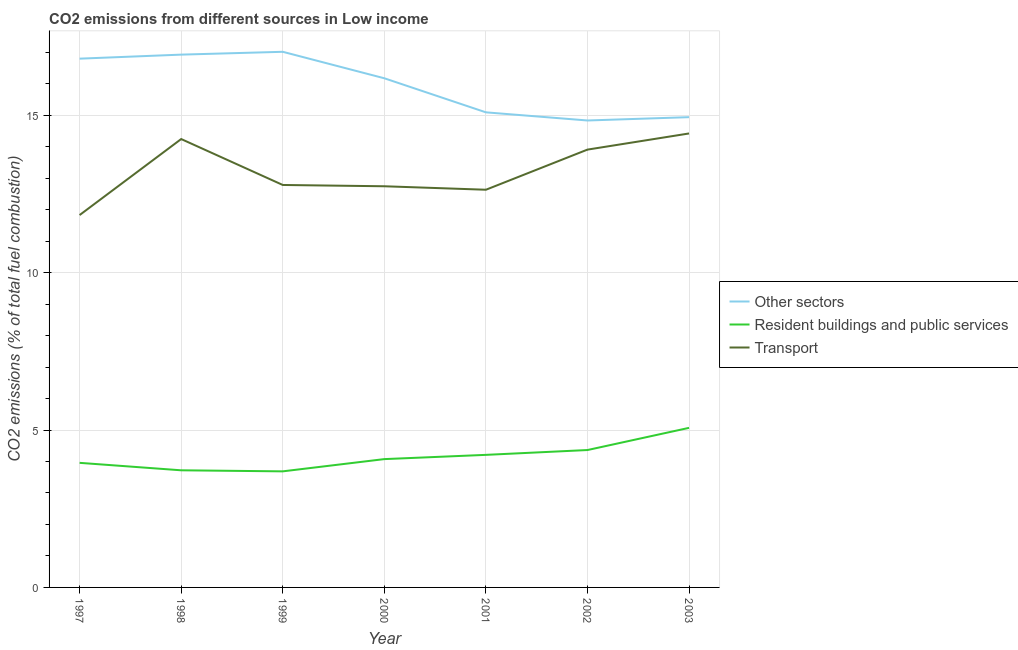How many different coloured lines are there?
Provide a succinct answer. 3. Does the line corresponding to percentage of co2 emissions from resident buildings and public services intersect with the line corresponding to percentage of co2 emissions from other sectors?
Ensure brevity in your answer.  No. Is the number of lines equal to the number of legend labels?
Give a very brief answer. Yes. What is the percentage of co2 emissions from resident buildings and public services in 2002?
Your response must be concise. 4.36. Across all years, what is the maximum percentage of co2 emissions from other sectors?
Provide a succinct answer. 17.01. Across all years, what is the minimum percentage of co2 emissions from resident buildings and public services?
Your answer should be very brief. 3.69. In which year was the percentage of co2 emissions from transport maximum?
Your answer should be very brief. 2003. In which year was the percentage of co2 emissions from resident buildings and public services minimum?
Keep it short and to the point. 1999. What is the total percentage of co2 emissions from other sectors in the graph?
Your response must be concise. 111.78. What is the difference between the percentage of co2 emissions from transport in 2000 and that in 2002?
Give a very brief answer. -1.16. What is the difference between the percentage of co2 emissions from transport in 1999 and the percentage of co2 emissions from resident buildings and public services in 2000?
Provide a short and direct response. 8.71. What is the average percentage of co2 emissions from resident buildings and public services per year?
Your answer should be compact. 4.16. In the year 2000, what is the difference between the percentage of co2 emissions from other sectors and percentage of co2 emissions from resident buildings and public services?
Your answer should be very brief. 12.1. What is the ratio of the percentage of co2 emissions from transport in 2001 to that in 2003?
Keep it short and to the point. 0.88. Is the difference between the percentage of co2 emissions from other sectors in 2001 and 2003 greater than the difference between the percentage of co2 emissions from transport in 2001 and 2003?
Your answer should be compact. Yes. What is the difference between the highest and the second highest percentage of co2 emissions from resident buildings and public services?
Keep it short and to the point. 0.7. What is the difference between the highest and the lowest percentage of co2 emissions from transport?
Your answer should be very brief. 2.59. In how many years, is the percentage of co2 emissions from transport greater than the average percentage of co2 emissions from transport taken over all years?
Offer a very short reply. 3. Is the percentage of co2 emissions from other sectors strictly less than the percentage of co2 emissions from resident buildings and public services over the years?
Keep it short and to the point. No. Are the values on the major ticks of Y-axis written in scientific E-notation?
Offer a very short reply. No. Does the graph contain any zero values?
Offer a very short reply. No. What is the title of the graph?
Ensure brevity in your answer.  CO2 emissions from different sources in Low income. Does "Ores and metals" appear as one of the legend labels in the graph?
Keep it short and to the point. No. What is the label or title of the X-axis?
Keep it short and to the point. Year. What is the label or title of the Y-axis?
Provide a short and direct response. CO2 emissions (% of total fuel combustion). What is the CO2 emissions (% of total fuel combustion) in Other sectors in 1997?
Give a very brief answer. 16.8. What is the CO2 emissions (% of total fuel combustion) in Resident buildings and public services in 1997?
Your answer should be compact. 3.96. What is the CO2 emissions (% of total fuel combustion) in Transport in 1997?
Keep it short and to the point. 11.83. What is the CO2 emissions (% of total fuel combustion) in Other sectors in 1998?
Make the answer very short. 16.93. What is the CO2 emissions (% of total fuel combustion) of Resident buildings and public services in 1998?
Provide a succinct answer. 3.72. What is the CO2 emissions (% of total fuel combustion) of Transport in 1998?
Give a very brief answer. 14.24. What is the CO2 emissions (% of total fuel combustion) of Other sectors in 1999?
Your response must be concise. 17.01. What is the CO2 emissions (% of total fuel combustion) of Resident buildings and public services in 1999?
Your response must be concise. 3.69. What is the CO2 emissions (% of total fuel combustion) in Transport in 1999?
Your answer should be very brief. 12.78. What is the CO2 emissions (% of total fuel combustion) of Other sectors in 2000?
Your answer should be very brief. 16.17. What is the CO2 emissions (% of total fuel combustion) in Resident buildings and public services in 2000?
Give a very brief answer. 4.08. What is the CO2 emissions (% of total fuel combustion) of Transport in 2000?
Make the answer very short. 12.74. What is the CO2 emissions (% of total fuel combustion) in Other sectors in 2001?
Provide a short and direct response. 15.09. What is the CO2 emissions (% of total fuel combustion) of Resident buildings and public services in 2001?
Offer a terse response. 4.21. What is the CO2 emissions (% of total fuel combustion) in Transport in 2001?
Your response must be concise. 12.63. What is the CO2 emissions (% of total fuel combustion) in Other sectors in 2002?
Provide a short and direct response. 14.83. What is the CO2 emissions (% of total fuel combustion) of Resident buildings and public services in 2002?
Your answer should be very brief. 4.36. What is the CO2 emissions (% of total fuel combustion) in Transport in 2002?
Provide a short and direct response. 13.91. What is the CO2 emissions (% of total fuel combustion) of Other sectors in 2003?
Your response must be concise. 14.94. What is the CO2 emissions (% of total fuel combustion) of Resident buildings and public services in 2003?
Keep it short and to the point. 5.07. What is the CO2 emissions (% of total fuel combustion) in Transport in 2003?
Offer a very short reply. 14.42. Across all years, what is the maximum CO2 emissions (% of total fuel combustion) in Other sectors?
Your answer should be compact. 17.01. Across all years, what is the maximum CO2 emissions (% of total fuel combustion) of Resident buildings and public services?
Offer a terse response. 5.07. Across all years, what is the maximum CO2 emissions (% of total fuel combustion) in Transport?
Your response must be concise. 14.42. Across all years, what is the minimum CO2 emissions (% of total fuel combustion) of Other sectors?
Your response must be concise. 14.83. Across all years, what is the minimum CO2 emissions (% of total fuel combustion) of Resident buildings and public services?
Keep it short and to the point. 3.69. Across all years, what is the minimum CO2 emissions (% of total fuel combustion) of Transport?
Provide a succinct answer. 11.83. What is the total CO2 emissions (% of total fuel combustion) in Other sectors in the graph?
Give a very brief answer. 111.78. What is the total CO2 emissions (% of total fuel combustion) of Resident buildings and public services in the graph?
Ensure brevity in your answer.  29.09. What is the total CO2 emissions (% of total fuel combustion) of Transport in the graph?
Offer a very short reply. 92.56. What is the difference between the CO2 emissions (% of total fuel combustion) of Other sectors in 1997 and that in 1998?
Offer a very short reply. -0.13. What is the difference between the CO2 emissions (% of total fuel combustion) of Resident buildings and public services in 1997 and that in 1998?
Give a very brief answer. 0.24. What is the difference between the CO2 emissions (% of total fuel combustion) of Transport in 1997 and that in 1998?
Ensure brevity in your answer.  -2.41. What is the difference between the CO2 emissions (% of total fuel combustion) of Other sectors in 1997 and that in 1999?
Keep it short and to the point. -0.22. What is the difference between the CO2 emissions (% of total fuel combustion) in Resident buildings and public services in 1997 and that in 1999?
Your response must be concise. 0.27. What is the difference between the CO2 emissions (% of total fuel combustion) of Transport in 1997 and that in 1999?
Provide a short and direct response. -0.96. What is the difference between the CO2 emissions (% of total fuel combustion) of Other sectors in 1997 and that in 2000?
Provide a succinct answer. 0.62. What is the difference between the CO2 emissions (% of total fuel combustion) in Resident buildings and public services in 1997 and that in 2000?
Provide a short and direct response. -0.12. What is the difference between the CO2 emissions (% of total fuel combustion) of Transport in 1997 and that in 2000?
Provide a short and direct response. -0.91. What is the difference between the CO2 emissions (% of total fuel combustion) of Other sectors in 1997 and that in 2001?
Offer a terse response. 1.71. What is the difference between the CO2 emissions (% of total fuel combustion) of Resident buildings and public services in 1997 and that in 2001?
Provide a short and direct response. -0.25. What is the difference between the CO2 emissions (% of total fuel combustion) in Transport in 1997 and that in 2001?
Provide a succinct answer. -0.8. What is the difference between the CO2 emissions (% of total fuel combustion) of Other sectors in 1997 and that in 2002?
Keep it short and to the point. 1.96. What is the difference between the CO2 emissions (% of total fuel combustion) in Resident buildings and public services in 1997 and that in 2002?
Provide a short and direct response. -0.41. What is the difference between the CO2 emissions (% of total fuel combustion) in Transport in 1997 and that in 2002?
Provide a succinct answer. -2.08. What is the difference between the CO2 emissions (% of total fuel combustion) in Other sectors in 1997 and that in 2003?
Your answer should be compact. 1.86. What is the difference between the CO2 emissions (% of total fuel combustion) of Resident buildings and public services in 1997 and that in 2003?
Ensure brevity in your answer.  -1.11. What is the difference between the CO2 emissions (% of total fuel combustion) of Transport in 1997 and that in 2003?
Provide a succinct answer. -2.59. What is the difference between the CO2 emissions (% of total fuel combustion) in Other sectors in 1998 and that in 1999?
Offer a terse response. -0.09. What is the difference between the CO2 emissions (% of total fuel combustion) in Resident buildings and public services in 1998 and that in 1999?
Offer a terse response. 0.03. What is the difference between the CO2 emissions (% of total fuel combustion) of Transport in 1998 and that in 1999?
Make the answer very short. 1.46. What is the difference between the CO2 emissions (% of total fuel combustion) in Other sectors in 1998 and that in 2000?
Provide a short and direct response. 0.75. What is the difference between the CO2 emissions (% of total fuel combustion) in Resident buildings and public services in 1998 and that in 2000?
Make the answer very short. -0.36. What is the difference between the CO2 emissions (% of total fuel combustion) in Transport in 1998 and that in 2000?
Provide a short and direct response. 1.5. What is the difference between the CO2 emissions (% of total fuel combustion) in Other sectors in 1998 and that in 2001?
Ensure brevity in your answer.  1.83. What is the difference between the CO2 emissions (% of total fuel combustion) of Resident buildings and public services in 1998 and that in 2001?
Offer a very short reply. -0.49. What is the difference between the CO2 emissions (% of total fuel combustion) in Transport in 1998 and that in 2001?
Your response must be concise. 1.61. What is the difference between the CO2 emissions (% of total fuel combustion) in Other sectors in 1998 and that in 2002?
Give a very brief answer. 2.09. What is the difference between the CO2 emissions (% of total fuel combustion) in Resident buildings and public services in 1998 and that in 2002?
Ensure brevity in your answer.  -0.64. What is the difference between the CO2 emissions (% of total fuel combustion) of Transport in 1998 and that in 2002?
Keep it short and to the point. 0.34. What is the difference between the CO2 emissions (% of total fuel combustion) in Other sectors in 1998 and that in 2003?
Provide a succinct answer. 1.99. What is the difference between the CO2 emissions (% of total fuel combustion) in Resident buildings and public services in 1998 and that in 2003?
Give a very brief answer. -1.35. What is the difference between the CO2 emissions (% of total fuel combustion) of Transport in 1998 and that in 2003?
Your answer should be compact. -0.18. What is the difference between the CO2 emissions (% of total fuel combustion) in Other sectors in 1999 and that in 2000?
Your answer should be compact. 0.84. What is the difference between the CO2 emissions (% of total fuel combustion) in Resident buildings and public services in 1999 and that in 2000?
Give a very brief answer. -0.39. What is the difference between the CO2 emissions (% of total fuel combustion) in Transport in 1999 and that in 2000?
Provide a succinct answer. 0.04. What is the difference between the CO2 emissions (% of total fuel combustion) in Other sectors in 1999 and that in 2001?
Offer a terse response. 1.92. What is the difference between the CO2 emissions (% of total fuel combustion) in Resident buildings and public services in 1999 and that in 2001?
Offer a very short reply. -0.52. What is the difference between the CO2 emissions (% of total fuel combustion) of Transport in 1999 and that in 2001?
Your answer should be very brief. 0.15. What is the difference between the CO2 emissions (% of total fuel combustion) of Other sectors in 1999 and that in 2002?
Your response must be concise. 2.18. What is the difference between the CO2 emissions (% of total fuel combustion) of Resident buildings and public services in 1999 and that in 2002?
Provide a succinct answer. -0.68. What is the difference between the CO2 emissions (% of total fuel combustion) in Transport in 1999 and that in 2002?
Offer a very short reply. -1.12. What is the difference between the CO2 emissions (% of total fuel combustion) of Other sectors in 1999 and that in 2003?
Provide a succinct answer. 2.08. What is the difference between the CO2 emissions (% of total fuel combustion) in Resident buildings and public services in 1999 and that in 2003?
Provide a succinct answer. -1.38. What is the difference between the CO2 emissions (% of total fuel combustion) of Transport in 1999 and that in 2003?
Give a very brief answer. -1.64. What is the difference between the CO2 emissions (% of total fuel combustion) of Other sectors in 2000 and that in 2001?
Your answer should be very brief. 1.08. What is the difference between the CO2 emissions (% of total fuel combustion) of Resident buildings and public services in 2000 and that in 2001?
Give a very brief answer. -0.13. What is the difference between the CO2 emissions (% of total fuel combustion) of Transport in 2000 and that in 2001?
Ensure brevity in your answer.  0.11. What is the difference between the CO2 emissions (% of total fuel combustion) of Other sectors in 2000 and that in 2002?
Offer a terse response. 1.34. What is the difference between the CO2 emissions (% of total fuel combustion) in Resident buildings and public services in 2000 and that in 2002?
Your answer should be compact. -0.29. What is the difference between the CO2 emissions (% of total fuel combustion) of Transport in 2000 and that in 2002?
Keep it short and to the point. -1.16. What is the difference between the CO2 emissions (% of total fuel combustion) in Other sectors in 2000 and that in 2003?
Offer a very short reply. 1.24. What is the difference between the CO2 emissions (% of total fuel combustion) of Resident buildings and public services in 2000 and that in 2003?
Ensure brevity in your answer.  -0.99. What is the difference between the CO2 emissions (% of total fuel combustion) of Transport in 2000 and that in 2003?
Make the answer very short. -1.68. What is the difference between the CO2 emissions (% of total fuel combustion) in Other sectors in 2001 and that in 2002?
Keep it short and to the point. 0.26. What is the difference between the CO2 emissions (% of total fuel combustion) of Resident buildings and public services in 2001 and that in 2002?
Ensure brevity in your answer.  -0.15. What is the difference between the CO2 emissions (% of total fuel combustion) in Transport in 2001 and that in 2002?
Offer a terse response. -1.27. What is the difference between the CO2 emissions (% of total fuel combustion) of Other sectors in 2001 and that in 2003?
Your answer should be very brief. 0.15. What is the difference between the CO2 emissions (% of total fuel combustion) in Resident buildings and public services in 2001 and that in 2003?
Give a very brief answer. -0.86. What is the difference between the CO2 emissions (% of total fuel combustion) in Transport in 2001 and that in 2003?
Offer a terse response. -1.79. What is the difference between the CO2 emissions (% of total fuel combustion) of Other sectors in 2002 and that in 2003?
Provide a succinct answer. -0.11. What is the difference between the CO2 emissions (% of total fuel combustion) of Resident buildings and public services in 2002 and that in 2003?
Your answer should be very brief. -0.7. What is the difference between the CO2 emissions (% of total fuel combustion) of Transport in 2002 and that in 2003?
Your answer should be very brief. -0.51. What is the difference between the CO2 emissions (% of total fuel combustion) of Other sectors in 1997 and the CO2 emissions (% of total fuel combustion) of Resident buildings and public services in 1998?
Keep it short and to the point. 13.08. What is the difference between the CO2 emissions (% of total fuel combustion) in Other sectors in 1997 and the CO2 emissions (% of total fuel combustion) in Transport in 1998?
Your answer should be compact. 2.55. What is the difference between the CO2 emissions (% of total fuel combustion) in Resident buildings and public services in 1997 and the CO2 emissions (% of total fuel combustion) in Transport in 1998?
Keep it short and to the point. -10.29. What is the difference between the CO2 emissions (% of total fuel combustion) in Other sectors in 1997 and the CO2 emissions (% of total fuel combustion) in Resident buildings and public services in 1999?
Provide a short and direct response. 13.11. What is the difference between the CO2 emissions (% of total fuel combustion) in Other sectors in 1997 and the CO2 emissions (% of total fuel combustion) in Transport in 1999?
Your response must be concise. 4.01. What is the difference between the CO2 emissions (% of total fuel combustion) in Resident buildings and public services in 1997 and the CO2 emissions (% of total fuel combustion) in Transport in 1999?
Keep it short and to the point. -8.83. What is the difference between the CO2 emissions (% of total fuel combustion) of Other sectors in 1997 and the CO2 emissions (% of total fuel combustion) of Resident buildings and public services in 2000?
Provide a short and direct response. 12.72. What is the difference between the CO2 emissions (% of total fuel combustion) of Other sectors in 1997 and the CO2 emissions (% of total fuel combustion) of Transport in 2000?
Ensure brevity in your answer.  4.05. What is the difference between the CO2 emissions (% of total fuel combustion) in Resident buildings and public services in 1997 and the CO2 emissions (% of total fuel combustion) in Transport in 2000?
Your response must be concise. -8.79. What is the difference between the CO2 emissions (% of total fuel combustion) of Other sectors in 1997 and the CO2 emissions (% of total fuel combustion) of Resident buildings and public services in 2001?
Give a very brief answer. 12.59. What is the difference between the CO2 emissions (% of total fuel combustion) of Other sectors in 1997 and the CO2 emissions (% of total fuel combustion) of Transport in 2001?
Your answer should be very brief. 4.16. What is the difference between the CO2 emissions (% of total fuel combustion) in Resident buildings and public services in 1997 and the CO2 emissions (% of total fuel combustion) in Transport in 2001?
Keep it short and to the point. -8.68. What is the difference between the CO2 emissions (% of total fuel combustion) in Other sectors in 1997 and the CO2 emissions (% of total fuel combustion) in Resident buildings and public services in 2002?
Give a very brief answer. 12.43. What is the difference between the CO2 emissions (% of total fuel combustion) in Other sectors in 1997 and the CO2 emissions (% of total fuel combustion) in Transport in 2002?
Keep it short and to the point. 2.89. What is the difference between the CO2 emissions (% of total fuel combustion) in Resident buildings and public services in 1997 and the CO2 emissions (% of total fuel combustion) in Transport in 2002?
Offer a terse response. -9.95. What is the difference between the CO2 emissions (% of total fuel combustion) of Other sectors in 1997 and the CO2 emissions (% of total fuel combustion) of Resident buildings and public services in 2003?
Keep it short and to the point. 11.73. What is the difference between the CO2 emissions (% of total fuel combustion) in Other sectors in 1997 and the CO2 emissions (% of total fuel combustion) in Transport in 2003?
Make the answer very short. 2.38. What is the difference between the CO2 emissions (% of total fuel combustion) in Resident buildings and public services in 1997 and the CO2 emissions (% of total fuel combustion) in Transport in 2003?
Provide a short and direct response. -10.46. What is the difference between the CO2 emissions (% of total fuel combustion) in Other sectors in 1998 and the CO2 emissions (% of total fuel combustion) in Resident buildings and public services in 1999?
Your response must be concise. 13.24. What is the difference between the CO2 emissions (% of total fuel combustion) of Other sectors in 1998 and the CO2 emissions (% of total fuel combustion) of Transport in 1999?
Ensure brevity in your answer.  4.14. What is the difference between the CO2 emissions (% of total fuel combustion) in Resident buildings and public services in 1998 and the CO2 emissions (% of total fuel combustion) in Transport in 1999?
Offer a very short reply. -9.06. What is the difference between the CO2 emissions (% of total fuel combustion) of Other sectors in 1998 and the CO2 emissions (% of total fuel combustion) of Resident buildings and public services in 2000?
Offer a terse response. 12.85. What is the difference between the CO2 emissions (% of total fuel combustion) of Other sectors in 1998 and the CO2 emissions (% of total fuel combustion) of Transport in 2000?
Offer a very short reply. 4.18. What is the difference between the CO2 emissions (% of total fuel combustion) of Resident buildings and public services in 1998 and the CO2 emissions (% of total fuel combustion) of Transport in 2000?
Your response must be concise. -9.02. What is the difference between the CO2 emissions (% of total fuel combustion) of Other sectors in 1998 and the CO2 emissions (% of total fuel combustion) of Resident buildings and public services in 2001?
Make the answer very short. 12.71. What is the difference between the CO2 emissions (% of total fuel combustion) in Other sectors in 1998 and the CO2 emissions (% of total fuel combustion) in Transport in 2001?
Ensure brevity in your answer.  4.29. What is the difference between the CO2 emissions (% of total fuel combustion) in Resident buildings and public services in 1998 and the CO2 emissions (% of total fuel combustion) in Transport in 2001?
Ensure brevity in your answer.  -8.91. What is the difference between the CO2 emissions (% of total fuel combustion) in Other sectors in 1998 and the CO2 emissions (% of total fuel combustion) in Resident buildings and public services in 2002?
Ensure brevity in your answer.  12.56. What is the difference between the CO2 emissions (% of total fuel combustion) in Other sectors in 1998 and the CO2 emissions (% of total fuel combustion) in Transport in 2002?
Offer a terse response. 3.02. What is the difference between the CO2 emissions (% of total fuel combustion) of Resident buildings and public services in 1998 and the CO2 emissions (% of total fuel combustion) of Transport in 2002?
Give a very brief answer. -10.19. What is the difference between the CO2 emissions (% of total fuel combustion) of Other sectors in 1998 and the CO2 emissions (% of total fuel combustion) of Resident buildings and public services in 2003?
Provide a short and direct response. 11.86. What is the difference between the CO2 emissions (% of total fuel combustion) in Other sectors in 1998 and the CO2 emissions (% of total fuel combustion) in Transport in 2003?
Offer a very short reply. 2.5. What is the difference between the CO2 emissions (% of total fuel combustion) of Resident buildings and public services in 1998 and the CO2 emissions (% of total fuel combustion) of Transport in 2003?
Give a very brief answer. -10.7. What is the difference between the CO2 emissions (% of total fuel combustion) in Other sectors in 1999 and the CO2 emissions (% of total fuel combustion) in Resident buildings and public services in 2000?
Make the answer very short. 12.94. What is the difference between the CO2 emissions (% of total fuel combustion) of Other sectors in 1999 and the CO2 emissions (% of total fuel combustion) of Transport in 2000?
Give a very brief answer. 4.27. What is the difference between the CO2 emissions (% of total fuel combustion) in Resident buildings and public services in 1999 and the CO2 emissions (% of total fuel combustion) in Transport in 2000?
Give a very brief answer. -9.06. What is the difference between the CO2 emissions (% of total fuel combustion) of Other sectors in 1999 and the CO2 emissions (% of total fuel combustion) of Resident buildings and public services in 2001?
Keep it short and to the point. 12.8. What is the difference between the CO2 emissions (% of total fuel combustion) in Other sectors in 1999 and the CO2 emissions (% of total fuel combustion) in Transport in 2001?
Your answer should be very brief. 4.38. What is the difference between the CO2 emissions (% of total fuel combustion) of Resident buildings and public services in 1999 and the CO2 emissions (% of total fuel combustion) of Transport in 2001?
Your answer should be compact. -8.95. What is the difference between the CO2 emissions (% of total fuel combustion) in Other sectors in 1999 and the CO2 emissions (% of total fuel combustion) in Resident buildings and public services in 2002?
Make the answer very short. 12.65. What is the difference between the CO2 emissions (% of total fuel combustion) of Other sectors in 1999 and the CO2 emissions (% of total fuel combustion) of Transport in 2002?
Your answer should be compact. 3.11. What is the difference between the CO2 emissions (% of total fuel combustion) of Resident buildings and public services in 1999 and the CO2 emissions (% of total fuel combustion) of Transport in 2002?
Your response must be concise. -10.22. What is the difference between the CO2 emissions (% of total fuel combustion) of Other sectors in 1999 and the CO2 emissions (% of total fuel combustion) of Resident buildings and public services in 2003?
Give a very brief answer. 11.95. What is the difference between the CO2 emissions (% of total fuel combustion) of Other sectors in 1999 and the CO2 emissions (% of total fuel combustion) of Transport in 2003?
Offer a very short reply. 2.59. What is the difference between the CO2 emissions (% of total fuel combustion) of Resident buildings and public services in 1999 and the CO2 emissions (% of total fuel combustion) of Transport in 2003?
Give a very brief answer. -10.73. What is the difference between the CO2 emissions (% of total fuel combustion) of Other sectors in 2000 and the CO2 emissions (% of total fuel combustion) of Resident buildings and public services in 2001?
Give a very brief answer. 11.96. What is the difference between the CO2 emissions (% of total fuel combustion) in Other sectors in 2000 and the CO2 emissions (% of total fuel combustion) in Transport in 2001?
Your response must be concise. 3.54. What is the difference between the CO2 emissions (% of total fuel combustion) in Resident buildings and public services in 2000 and the CO2 emissions (% of total fuel combustion) in Transport in 2001?
Provide a succinct answer. -8.56. What is the difference between the CO2 emissions (% of total fuel combustion) of Other sectors in 2000 and the CO2 emissions (% of total fuel combustion) of Resident buildings and public services in 2002?
Give a very brief answer. 11.81. What is the difference between the CO2 emissions (% of total fuel combustion) of Other sectors in 2000 and the CO2 emissions (% of total fuel combustion) of Transport in 2002?
Your answer should be compact. 2.27. What is the difference between the CO2 emissions (% of total fuel combustion) in Resident buildings and public services in 2000 and the CO2 emissions (% of total fuel combustion) in Transport in 2002?
Provide a short and direct response. -9.83. What is the difference between the CO2 emissions (% of total fuel combustion) in Other sectors in 2000 and the CO2 emissions (% of total fuel combustion) in Resident buildings and public services in 2003?
Provide a succinct answer. 11.1. What is the difference between the CO2 emissions (% of total fuel combustion) in Other sectors in 2000 and the CO2 emissions (% of total fuel combustion) in Transport in 2003?
Offer a terse response. 1.75. What is the difference between the CO2 emissions (% of total fuel combustion) of Resident buildings and public services in 2000 and the CO2 emissions (% of total fuel combustion) of Transport in 2003?
Give a very brief answer. -10.34. What is the difference between the CO2 emissions (% of total fuel combustion) in Other sectors in 2001 and the CO2 emissions (% of total fuel combustion) in Resident buildings and public services in 2002?
Provide a succinct answer. 10.73. What is the difference between the CO2 emissions (% of total fuel combustion) of Other sectors in 2001 and the CO2 emissions (% of total fuel combustion) of Transport in 2002?
Keep it short and to the point. 1.18. What is the difference between the CO2 emissions (% of total fuel combustion) in Resident buildings and public services in 2001 and the CO2 emissions (% of total fuel combustion) in Transport in 2002?
Make the answer very short. -9.7. What is the difference between the CO2 emissions (% of total fuel combustion) in Other sectors in 2001 and the CO2 emissions (% of total fuel combustion) in Resident buildings and public services in 2003?
Keep it short and to the point. 10.02. What is the difference between the CO2 emissions (% of total fuel combustion) in Other sectors in 2001 and the CO2 emissions (% of total fuel combustion) in Transport in 2003?
Provide a succinct answer. 0.67. What is the difference between the CO2 emissions (% of total fuel combustion) of Resident buildings and public services in 2001 and the CO2 emissions (% of total fuel combustion) of Transport in 2003?
Your answer should be very brief. -10.21. What is the difference between the CO2 emissions (% of total fuel combustion) in Other sectors in 2002 and the CO2 emissions (% of total fuel combustion) in Resident buildings and public services in 2003?
Provide a short and direct response. 9.76. What is the difference between the CO2 emissions (% of total fuel combustion) in Other sectors in 2002 and the CO2 emissions (% of total fuel combustion) in Transport in 2003?
Keep it short and to the point. 0.41. What is the difference between the CO2 emissions (% of total fuel combustion) of Resident buildings and public services in 2002 and the CO2 emissions (% of total fuel combustion) of Transport in 2003?
Provide a short and direct response. -10.06. What is the average CO2 emissions (% of total fuel combustion) of Other sectors per year?
Your response must be concise. 15.97. What is the average CO2 emissions (% of total fuel combustion) in Resident buildings and public services per year?
Offer a very short reply. 4.16. What is the average CO2 emissions (% of total fuel combustion) of Transport per year?
Offer a terse response. 13.22. In the year 1997, what is the difference between the CO2 emissions (% of total fuel combustion) in Other sectors and CO2 emissions (% of total fuel combustion) in Resident buildings and public services?
Keep it short and to the point. 12.84. In the year 1997, what is the difference between the CO2 emissions (% of total fuel combustion) in Other sectors and CO2 emissions (% of total fuel combustion) in Transport?
Provide a succinct answer. 4.97. In the year 1997, what is the difference between the CO2 emissions (% of total fuel combustion) in Resident buildings and public services and CO2 emissions (% of total fuel combustion) in Transport?
Ensure brevity in your answer.  -7.87. In the year 1998, what is the difference between the CO2 emissions (% of total fuel combustion) of Other sectors and CO2 emissions (% of total fuel combustion) of Resident buildings and public services?
Your answer should be very brief. 13.2. In the year 1998, what is the difference between the CO2 emissions (% of total fuel combustion) of Other sectors and CO2 emissions (% of total fuel combustion) of Transport?
Your answer should be very brief. 2.68. In the year 1998, what is the difference between the CO2 emissions (% of total fuel combustion) of Resident buildings and public services and CO2 emissions (% of total fuel combustion) of Transport?
Your response must be concise. -10.52. In the year 1999, what is the difference between the CO2 emissions (% of total fuel combustion) in Other sectors and CO2 emissions (% of total fuel combustion) in Resident buildings and public services?
Offer a very short reply. 13.33. In the year 1999, what is the difference between the CO2 emissions (% of total fuel combustion) of Other sectors and CO2 emissions (% of total fuel combustion) of Transport?
Give a very brief answer. 4.23. In the year 1999, what is the difference between the CO2 emissions (% of total fuel combustion) of Resident buildings and public services and CO2 emissions (% of total fuel combustion) of Transport?
Keep it short and to the point. -9.1. In the year 2000, what is the difference between the CO2 emissions (% of total fuel combustion) of Other sectors and CO2 emissions (% of total fuel combustion) of Resident buildings and public services?
Offer a very short reply. 12.1. In the year 2000, what is the difference between the CO2 emissions (% of total fuel combustion) in Other sectors and CO2 emissions (% of total fuel combustion) in Transport?
Ensure brevity in your answer.  3.43. In the year 2000, what is the difference between the CO2 emissions (% of total fuel combustion) in Resident buildings and public services and CO2 emissions (% of total fuel combustion) in Transport?
Your answer should be very brief. -8.67. In the year 2001, what is the difference between the CO2 emissions (% of total fuel combustion) in Other sectors and CO2 emissions (% of total fuel combustion) in Resident buildings and public services?
Offer a very short reply. 10.88. In the year 2001, what is the difference between the CO2 emissions (% of total fuel combustion) in Other sectors and CO2 emissions (% of total fuel combustion) in Transport?
Ensure brevity in your answer.  2.46. In the year 2001, what is the difference between the CO2 emissions (% of total fuel combustion) in Resident buildings and public services and CO2 emissions (% of total fuel combustion) in Transport?
Your answer should be compact. -8.42. In the year 2002, what is the difference between the CO2 emissions (% of total fuel combustion) of Other sectors and CO2 emissions (% of total fuel combustion) of Resident buildings and public services?
Offer a very short reply. 10.47. In the year 2002, what is the difference between the CO2 emissions (% of total fuel combustion) of Other sectors and CO2 emissions (% of total fuel combustion) of Transport?
Give a very brief answer. 0.93. In the year 2002, what is the difference between the CO2 emissions (% of total fuel combustion) of Resident buildings and public services and CO2 emissions (% of total fuel combustion) of Transport?
Offer a terse response. -9.54. In the year 2003, what is the difference between the CO2 emissions (% of total fuel combustion) of Other sectors and CO2 emissions (% of total fuel combustion) of Resident buildings and public services?
Offer a very short reply. 9.87. In the year 2003, what is the difference between the CO2 emissions (% of total fuel combustion) of Other sectors and CO2 emissions (% of total fuel combustion) of Transport?
Keep it short and to the point. 0.52. In the year 2003, what is the difference between the CO2 emissions (% of total fuel combustion) of Resident buildings and public services and CO2 emissions (% of total fuel combustion) of Transport?
Your answer should be very brief. -9.35. What is the ratio of the CO2 emissions (% of total fuel combustion) in Resident buildings and public services in 1997 to that in 1998?
Your response must be concise. 1.06. What is the ratio of the CO2 emissions (% of total fuel combustion) in Transport in 1997 to that in 1998?
Make the answer very short. 0.83. What is the ratio of the CO2 emissions (% of total fuel combustion) of Other sectors in 1997 to that in 1999?
Your answer should be very brief. 0.99. What is the ratio of the CO2 emissions (% of total fuel combustion) of Resident buildings and public services in 1997 to that in 1999?
Offer a terse response. 1.07. What is the ratio of the CO2 emissions (% of total fuel combustion) in Transport in 1997 to that in 1999?
Your answer should be very brief. 0.93. What is the ratio of the CO2 emissions (% of total fuel combustion) of Resident buildings and public services in 1997 to that in 2000?
Provide a succinct answer. 0.97. What is the ratio of the CO2 emissions (% of total fuel combustion) in Transport in 1997 to that in 2000?
Your answer should be compact. 0.93. What is the ratio of the CO2 emissions (% of total fuel combustion) in Other sectors in 1997 to that in 2001?
Make the answer very short. 1.11. What is the ratio of the CO2 emissions (% of total fuel combustion) of Resident buildings and public services in 1997 to that in 2001?
Provide a short and direct response. 0.94. What is the ratio of the CO2 emissions (% of total fuel combustion) of Transport in 1997 to that in 2001?
Offer a terse response. 0.94. What is the ratio of the CO2 emissions (% of total fuel combustion) of Other sectors in 1997 to that in 2002?
Ensure brevity in your answer.  1.13. What is the ratio of the CO2 emissions (% of total fuel combustion) in Resident buildings and public services in 1997 to that in 2002?
Ensure brevity in your answer.  0.91. What is the ratio of the CO2 emissions (% of total fuel combustion) in Transport in 1997 to that in 2002?
Offer a very short reply. 0.85. What is the ratio of the CO2 emissions (% of total fuel combustion) of Other sectors in 1997 to that in 2003?
Offer a terse response. 1.12. What is the ratio of the CO2 emissions (% of total fuel combustion) of Resident buildings and public services in 1997 to that in 2003?
Your answer should be very brief. 0.78. What is the ratio of the CO2 emissions (% of total fuel combustion) in Transport in 1997 to that in 2003?
Your answer should be very brief. 0.82. What is the ratio of the CO2 emissions (% of total fuel combustion) of Resident buildings and public services in 1998 to that in 1999?
Keep it short and to the point. 1.01. What is the ratio of the CO2 emissions (% of total fuel combustion) of Transport in 1998 to that in 1999?
Give a very brief answer. 1.11. What is the ratio of the CO2 emissions (% of total fuel combustion) of Other sectors in 1998 to that in 2000?
Offer a terse response. 1.05. What is the ratio of the CO2 emissions (% of total fuel combustion) of Resident buildings and public services in 1998 to that in 2000?
Provide a succinct answer. 0.91. What is the ratio of the CO2 emissions (% of total fuel combustion) in Transport in 1998 to that in 2000?
Your answer should be compact. 1.12. What is the ratio of the CO2 emissions (% of total fuel combustion) in Other sectors in 1998 to that in 2001?
Make the answer very short. 1.12. What is the ratio of the CO2 emissions (% of total fuel combustion) of Resident buildings and public services in 1998 to that in 2001?
Your answer should be very brief. 0.88. What is the ratio of the CO2 emissions (% of total fuel combustion) of Transport in 1998 to that in 2001?
Give a very brief answer. 1.13. What is the ratio of the CO2 emissions (% of total fuel combustion) in Other sectors in 1998 to that in 2002?
Your response must be concise. 1.14. What is the ratio of the CO2 emissions (% of total fuel combustion) in Resident buildings and public services in 1998 to that in 2002?
Give a very brief answer. 0.85. What is the ratio of the CO2 emissions (% of total fuel combustion) of Transport in 1998 to that in 2002?
Your answer should be compact. 1.02. What is the ratio of the CO2 emissions (% of total fuel combustion) in Other sectors in 1998 to that in 2003?
Your response must be concise. 1.13. What is the ratio of the CO2 emissions (% of total fuel combustion) in Resident buildings and public services in 1998 to that in 2003?
Your answer should be compact. 0.73. What is the ratio of the CO2 emissions (% of total fuel combustion) in Other sectors in 1999 to that in 2000?
Your answer should be compact. 1.05. What is the ratio of the CO2 emissions (% of total fuel combustion) of Resident buildings and public services in 1999 to that in 2000?
Your response must be concise. 0.9. What is the ratio of the CO2 emissions (% of total fuel combustion) of Transport in 1999 to that in 2000?
Offer a terse response. 1. What is the ratio of the CO2 emissions (% of total fuel combustion) in Other sectors in 1999 to that in 2001?
Offer a terse response. 1.13. What is the ratio of the CO2 emissions (% of total fuel combustion) of Resident buildings and public services in 1999 to that in 2001?
Provide a succinct answer. 0.88. What is the ratio of the CO2 emissions (% of total fuel combustion) in Other sectors in 1999 to that in 2002?
Your response must be concise. 1.15. What is the ratio of the CO2 emissions (% of total fuel combustion) of Resident buildings and public services in 1999 to that in 2002?
Ensure brevity in your answer.  0.84. What is the ratio of the CO2 emissions (% of total fuel combustion) of Transport in 1999 to that in 2002?
Offer a very short reply. 0.92. What is the ratio of the CO2 emissions (% of total fuel combustion) of Other sectors in 1999 to that in 2003?
Keep it short and to the point. 1.14. What is the ratio of the CO2 emissions (% of total fuel combustion) in Resident buildings and public services in 1999 to that in 2003?
Offer a terse response. 0.73. What is the ratio of the CO2 emissions (% of total fuel combustion) in Transport in 1999 to that in 2003?
Your answer should be very brief. 0.89. What is the ratio of the CO2 emissions (% of total fuel combustion) in Other sectors in 2000 to that in 2001?
Give a very brief answer. 1.07. What is the ratio of the CO2 emissions (% of total fuel combustion) in Resident buildings and public services in 2000 to that in 2001?
Give a very brief answer. 0.97. What is the ratio of the CO2 emissions (% of total fuel combustion) of Transport in 2000 to that in 2001?
Give a very brief answer. 1.01. What is the ratio of the CO2 emissions (% of total fuel combustion) in Other sectors in 2000 to that in 2002?
Provide a succinct answer. 1.09. What is the ratio of the CO2 emissions (% of total fuel combustion) in Resident buildings and public services in 2000 to that in 2002?
Give a very brief answer. 0.93. What is the ratio of the CO2 emissions (% of total fuel combustion) in Transport in 2000 to that in 2002?
Your response must be concise. 0.92. What is the ratio of the CO2 emissions (% of total fuel combustion) in Other sectors in 2000 to that in 2003?
Your answer should be very brief. 1.08. What is the ratio of the CO2 emissions (% of total fuel combustion) in Resident buildings and public services in 2000 to that in 2003?
Provide a succinct answer. 0.8. What is the ratio of the CO2 emissions (% of total fuel combustion) in Transport in 2000 to that in 2003?
Offer a terse response. 0.88. What is the ratio of the CO2 emissions (% of total fuel combustion) in Other sectors in 2001 to that in 2002?
Offer a very short reply. 1.02. What is the ratio of the CO2 emissions (% of total fuel combustion) in Resident buildings and public services in 2001 to that in 2002?
Provide a short and direct response. 0.96. What is the ratio of the CO2 emissions (% of total fuel combustion) in Transport in 2001 to that in 2002?
Provide a succinct answer. 0.91. What is the ratio of the CO2 emissions (% of total fuel combustion) of Other sectors in 2001 to that in 2003?
Provide a succinct answer. 1.01. What is the ratio of the CO2 emissions (% of total fuel combustion) of Resident buildings and public services in 2001 to that in 2003?
Provide a succinct answer. 0.83. What is the ratio of the CO2 emissions (% of total fuel combustion) in Transport in 2001 to that in 2003?
Keep it short and to the point. 0.88. What is the ratio of the CO2 emissions (% of total fuel combustion) in Other sectors in 2002 to that in 2003?
Offer a terse response. 0.99. What is the ratio of the CO2 emissions (% of total fuel combustion) of Resident buildings and public services in 2002 to that in 2003?
Your answer should be very brief. 0.86. What is the ratio of the CO2 emissions (% of total fuel combustion) in Transport in 2002 to that in 2003?
Offer a terse response. 0.96. What is the difference between the highest and the second highest CO2 emissions (% of total fuel combustion) in Other sectors?
Offer a terse response. 0.09. What is the difference between the highest and the second highest CO2 emissions (% of total fuel combustion) in Resident buildings and public services?
Offer a very short reply. 0.7. What is the difference between the highest and the second highest CO2 emissions (% of total fuel combustion) in Transport?
Provide a succinct answer. 0.18. What is the difference between the highest and the lowest CO2 emissions (% of total fuel combustion) of Other sectors?
Offer a terse response. 2.18. What is the difference between the highest and the lowest CO2 emissions (% of total fuel combustion) in Resident buildings and public services?
Your response must be concise. 1.38. What is the difference between the highest and the lowest CO2 emissions (% of total fuel combustion) in Transport?
Offer a very short reply. 2.59. 